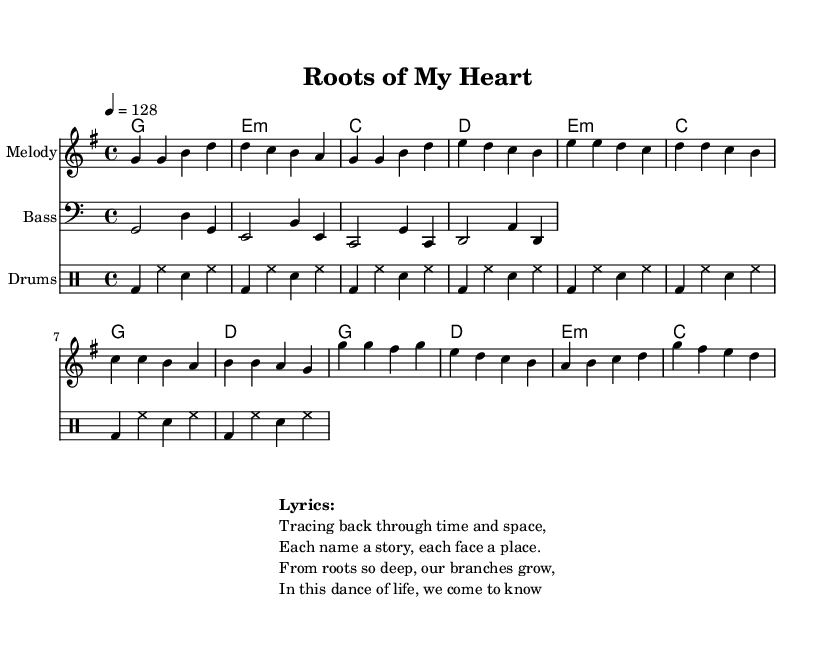What is the key signature of this music? The key signature is G major, which has one sharp (F#).
Answer: G major What is the time signature of this music? The time signature is 4/4, which means there are four beats in each measure.
Answer: 4/4 What is the tempo of this music? The tempo is 128 beats per minute, indicated by the tempo marking.
Answer: 128 How many measures are in the chorus? The chorus consists of four measures, as outlined in the music notation.
Answer: 4 What is the instrument name for the staff showing the melody? The instrument name for the staff showing the melody is "Melody," as indicated in the staff header.
Answer: Melody Which section of the song contains the lyrics "Tracing back through time and space"? These lyrics are part of the verse section, as they are placed above the corresponding melody notes.
Answer: Verse What type of musical style does this piece represent? The piece represents Dance pop, characterized by upbeat tempos and danceable rhythms.
Answer: Dance pop 